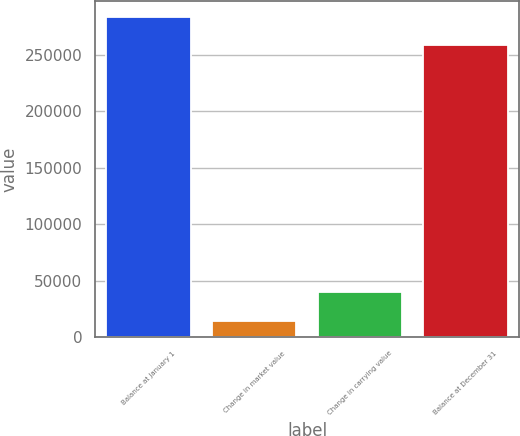<chart> <loc_0><loc_0><loc_500><loc_500><bar_chart><fcel>Balance at January 1<fcel>Change in market value<fcel>Change in carrying value<fcel>Balance at December 31<nl><fcel>283265<fcel>14544<fcel>39529<fcel>258280<nl></chart> 